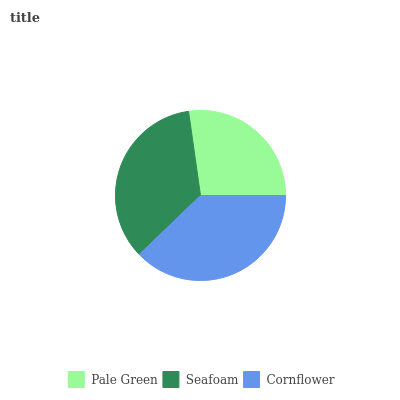Is Pale Green the minimum?
Answer yes or no. Yes. Is Cornflower the maximum?
Answer yes or no. Yes. Is Seafoam the minimum?
Answer yes or no. No. Is Seafoam the maximum?
Answer yes or no. No. Is Seafoam greater than Pale Green?
Answer yes or no. Yes. Is Pale Green less than Seafoam?
Answer yes or no. Yes. Is Pale Green greater than Seafoam?
Answer yes or no. No. Is Seafoam less than Pale Green?
Answer yes or no. No. Is Seafoam the high median?
Answer yes or no. Yes. Is Seafoam the low median?
Answer yes or no. Yes. Is Pale Green the high median?
Answer yes or no. No. Is Pale Green the low median?
Answer yes or no. No. 